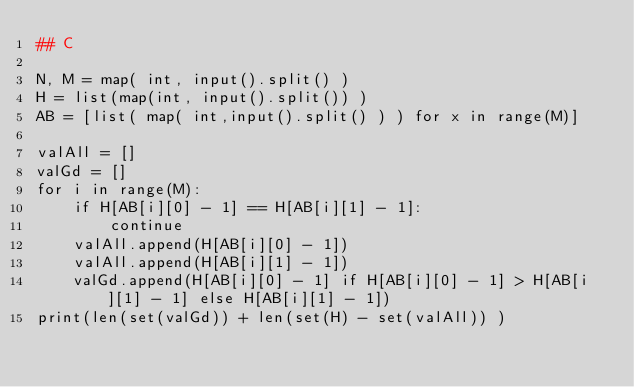<code> <loc_0><loc_0><loc_500><loc_500><_Python_>## C

N, M = map( int, input().split() )
H = list(map(int, input().split()) )
AB = [list( map( int,input().split() ) ) for x in range(M)]

valAll = []
valGd = []
for i in range(M):
    if H[AB[i][0] - 1] == H[AB[i][1] - 1]:
        continue
    valAll.append(H[AB[i][0] - 1])
    valAll.append(H[AB[i][1] - 1])
    valGd.append(H[AB[i][0] - 1] if H[AB[i][0] - 1] > H[AB[i][1] - 1] else H[AB[i][1] - 1])
print(len(set(valGd)) + len(set(H) - set(valAll)) )</code> 